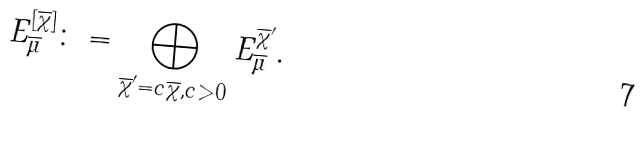<formula> <loc_0><loc_0><loc_500><loc_500>E ^ { [ \overline { \chi } ] } _ { \overline { \mu } } \colon = \bigoplus _ { \overline { \chi } ^ { \prime } = c \overline { \chi } , c > 0 } E ^ { \overline { \chi } ^ { \prime } } _ { \overline { \mu } } .</formula> 